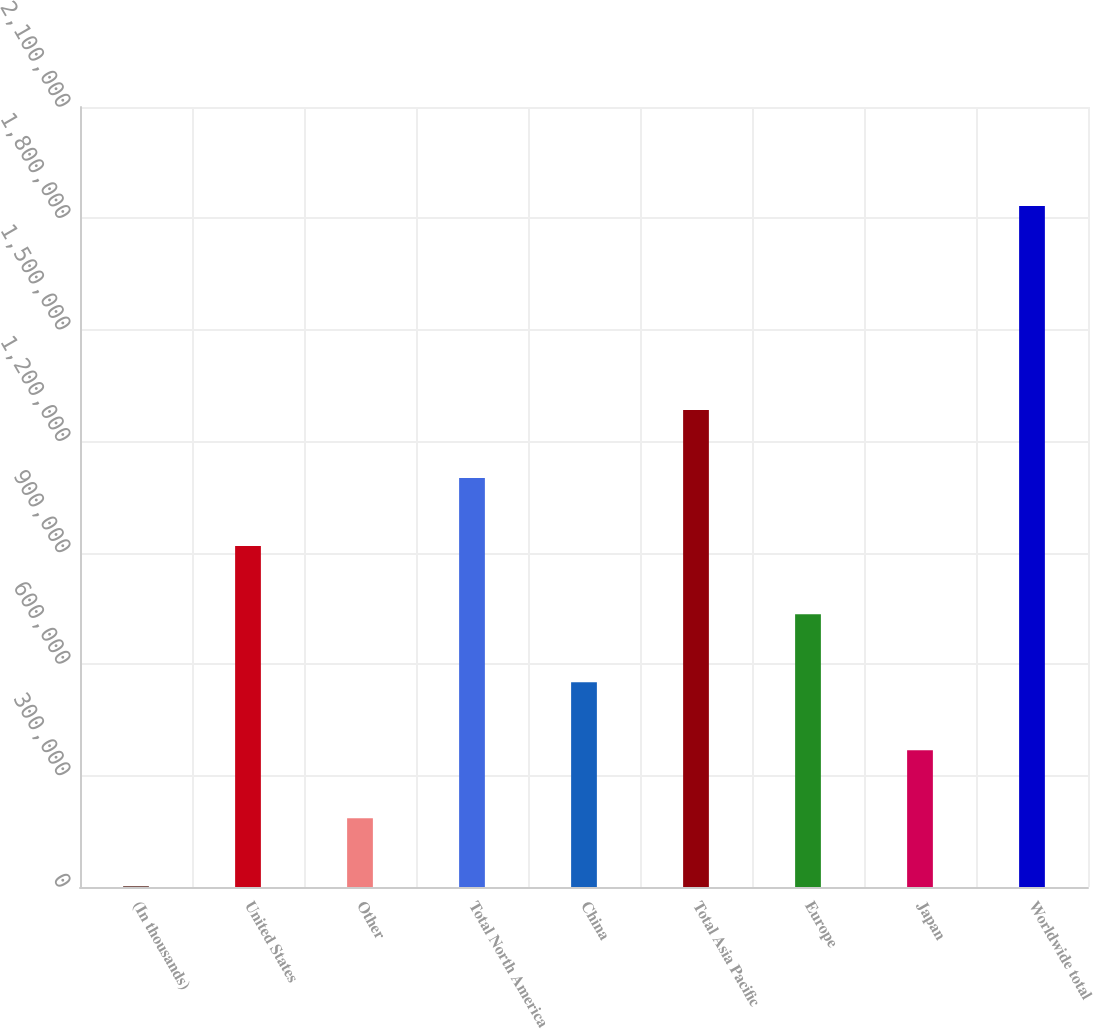Convert chart. <chart><loc_0><loc_0><loc_500><loc_500><bar_chart><fcel>(In thousands)<fcel>United States<fcel>Other<fcel>Total North America<fcel>China<fcel>Total Asia Pacific<fcel>Europe<fcel>Japan<fcel>Worldwide total<nl><fcel>2010<fcel>917782<fcel>185164<fcel>1.10094e+06<fcel>551473<fcel>1.28409e+06<fcel>734628<fcel>368319<fcel>1.83355e+06<nl></chart> 